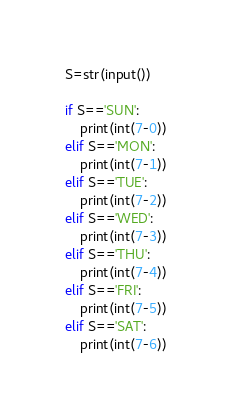<code> <loc_0><loc_0><loc_500><loc_500><_Python_>S=str(input())

if S=='SUN':
    print(int(7-0))
elif S=='MON':
    print(int(7-1))
elif S=='TUE':
    print(int(7-2))
elif S=='WED':
    print(int(7-3))
elif S=='THU':
    print(int(7-4))
elif S=='FRI':
    print(int(7-5))
elif S=='SAT':
    print(int(7-6))</code> 